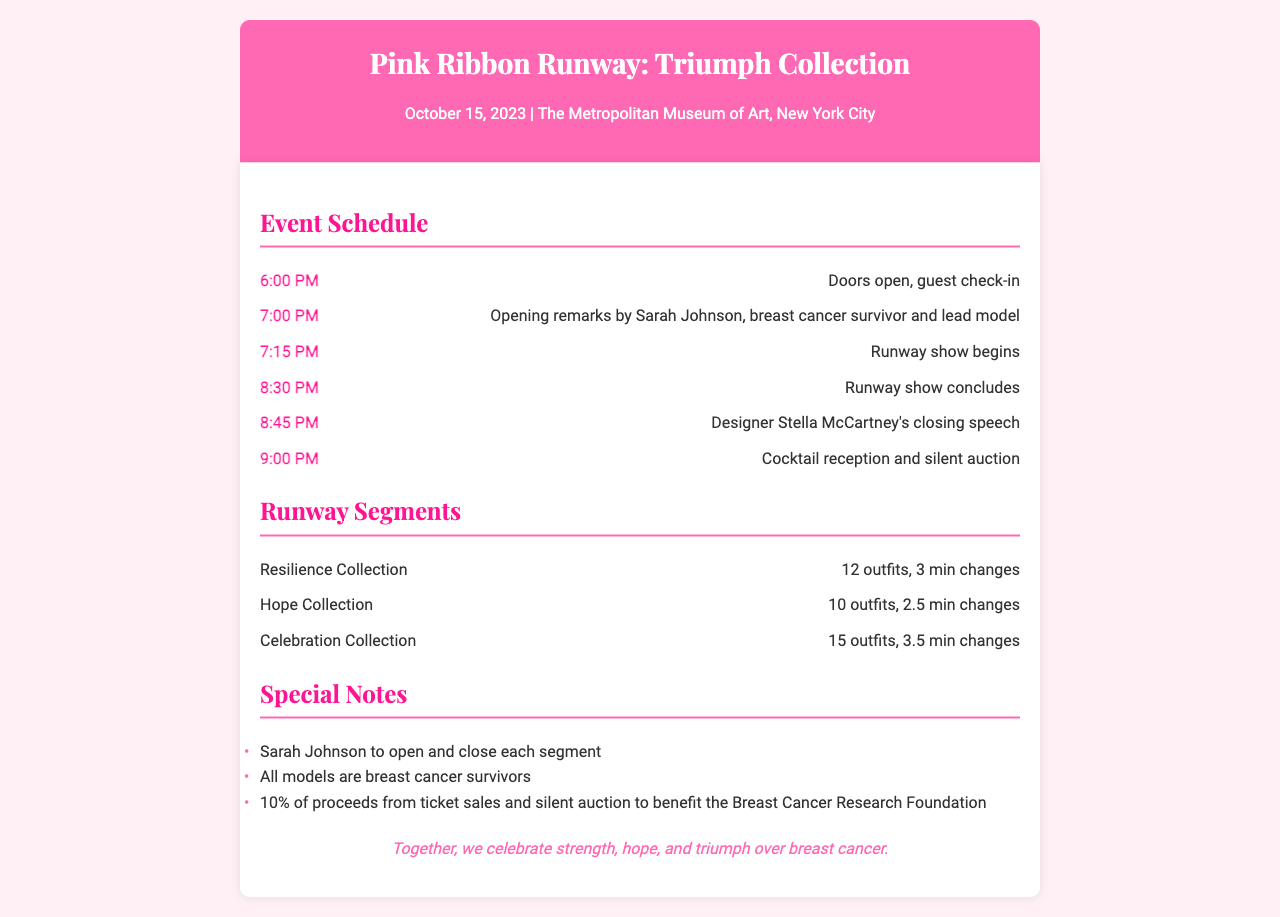What time do doors open? The schedule states that doors open at 6:00 PM.
Answer: 6:00 PM Who is delivering the opening remarks? The schedule indicates that Sarah Johnson, a breast cancer survivor and lead model, will give the opening remarks.
Answer: Sarah Johnson How many outfits are in the Resilience Collection? The runway segments detail that the Resilience Collection has 12 outfits.
Answer: 12 outfits What is the total duration of the runway show? The runway show starts at 7:15 PM and concludes at 8:30 PM, making the total duration 1 hour and 15 minutes.
Answer: 1 hour and 15 minutes What percentage of proceeds goes to the Breast Cancer Research Foundation? The special notes mention that 10% of proceeds from ticket sales and silent auction benefit the Breast Cancer Research Foundation.
Answer: 10% How long is the outfit change for the Celebration Collection? The runway segments state that the outfit change for the Celebration Collection takes 3.5 minutes.
Answer: 3.5 min Who closes each segment of the runway show? The special notes indicate that Sarah Johnson will open and close each segment.
Answer: Sarah Johnson What type of event is being held? The document is about a fashion show called the Pink Ribbon Runway.
Answer: Fashion show 